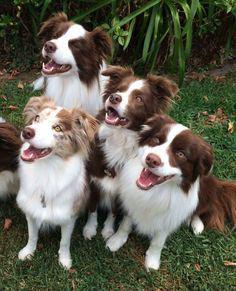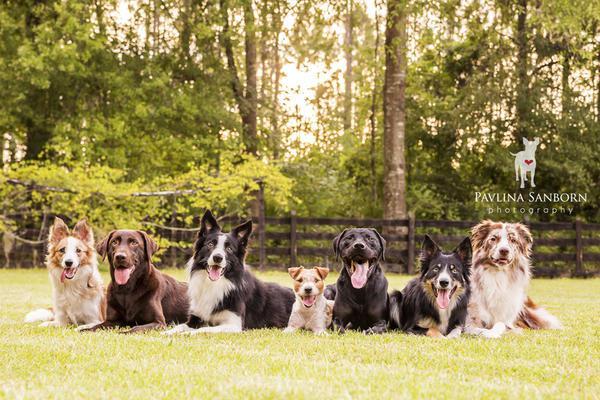The first image is the image on the left, the second image is the image on the right. Assess this claim about the two images: "A horizontal row of reclining dogs poses in front of some type of rail structure.". Correct or not? Answer yes or no. Yes. The first image is the image on the left, the second image is the image on the right. Considering the images on both sides, is "There are four dogs in the left image." valid? Answer yes or no. Yes. 